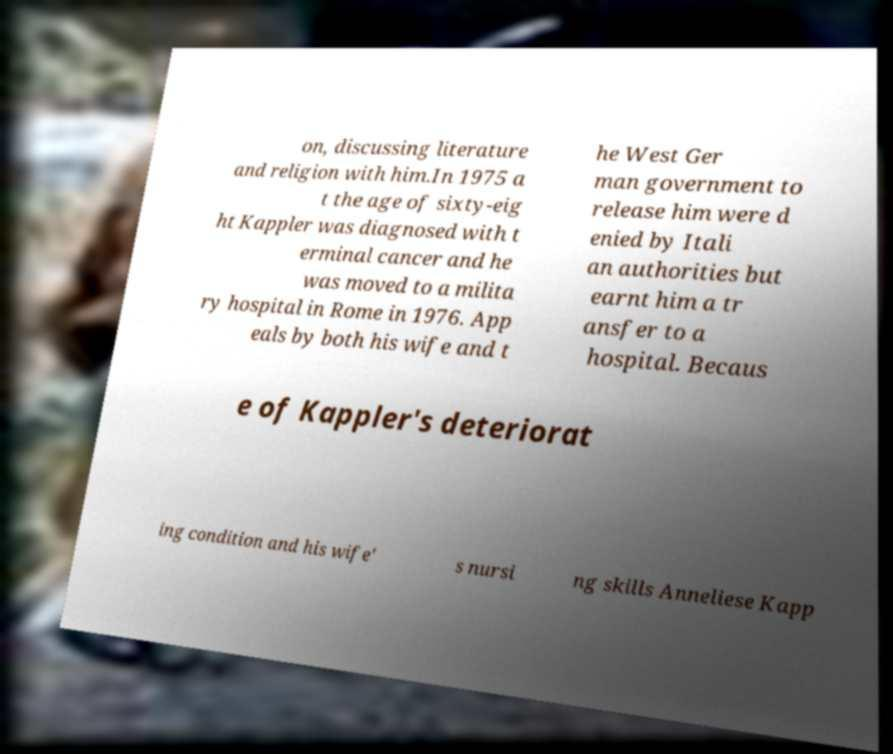What messages or text are displayed in this image? I need them in a readable, typed format. on, discussing literature and religion with him.In 1975 a t the age of sixty-eig ht Kappler was diagnosed with t erminal cancer and he was moved to a milita ry hospital in Rome in 1976. App eals by both his wife and t he West Ger man government to release him were d enied by Itali an authorities but earnt him a tr ansfer to a hospital. Becaus e of Kappler's deteriorat ing condition and his wife' s nursi ng skills Anneliese Kapp 